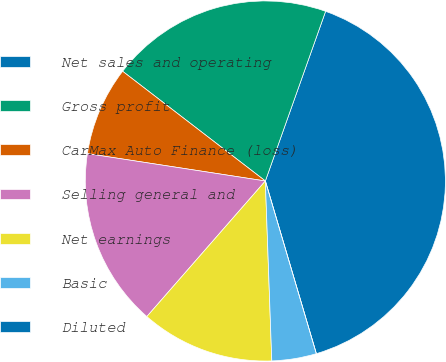Convert chart. <chart><loc_0><loc_0><loc_500><loc_500><pie_chart><fcel>Net sales and operating<fcel>Gross profit<fcel>CarMax Auto Finance (loss)<fcel>Selling general and<fcel>Net earnings<fcel>Basic<fcel>Diluted<nl><fcel>40.0%<fcel>20.0%<fcel>8.0%<fcel>16.0%<fcel>12.0%<fcel>4.0%<fcel>0.0%<nl></chart> 